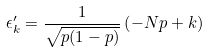Convert formula to latex. <formula><loc_0><loc_0><loc_500><loc_500>\epsilon _ { k } ^ { \prime } = \frac { 1 } { \sqrt { p ( 1 - p ) } } \left ( - N p + k \right )</formula> 